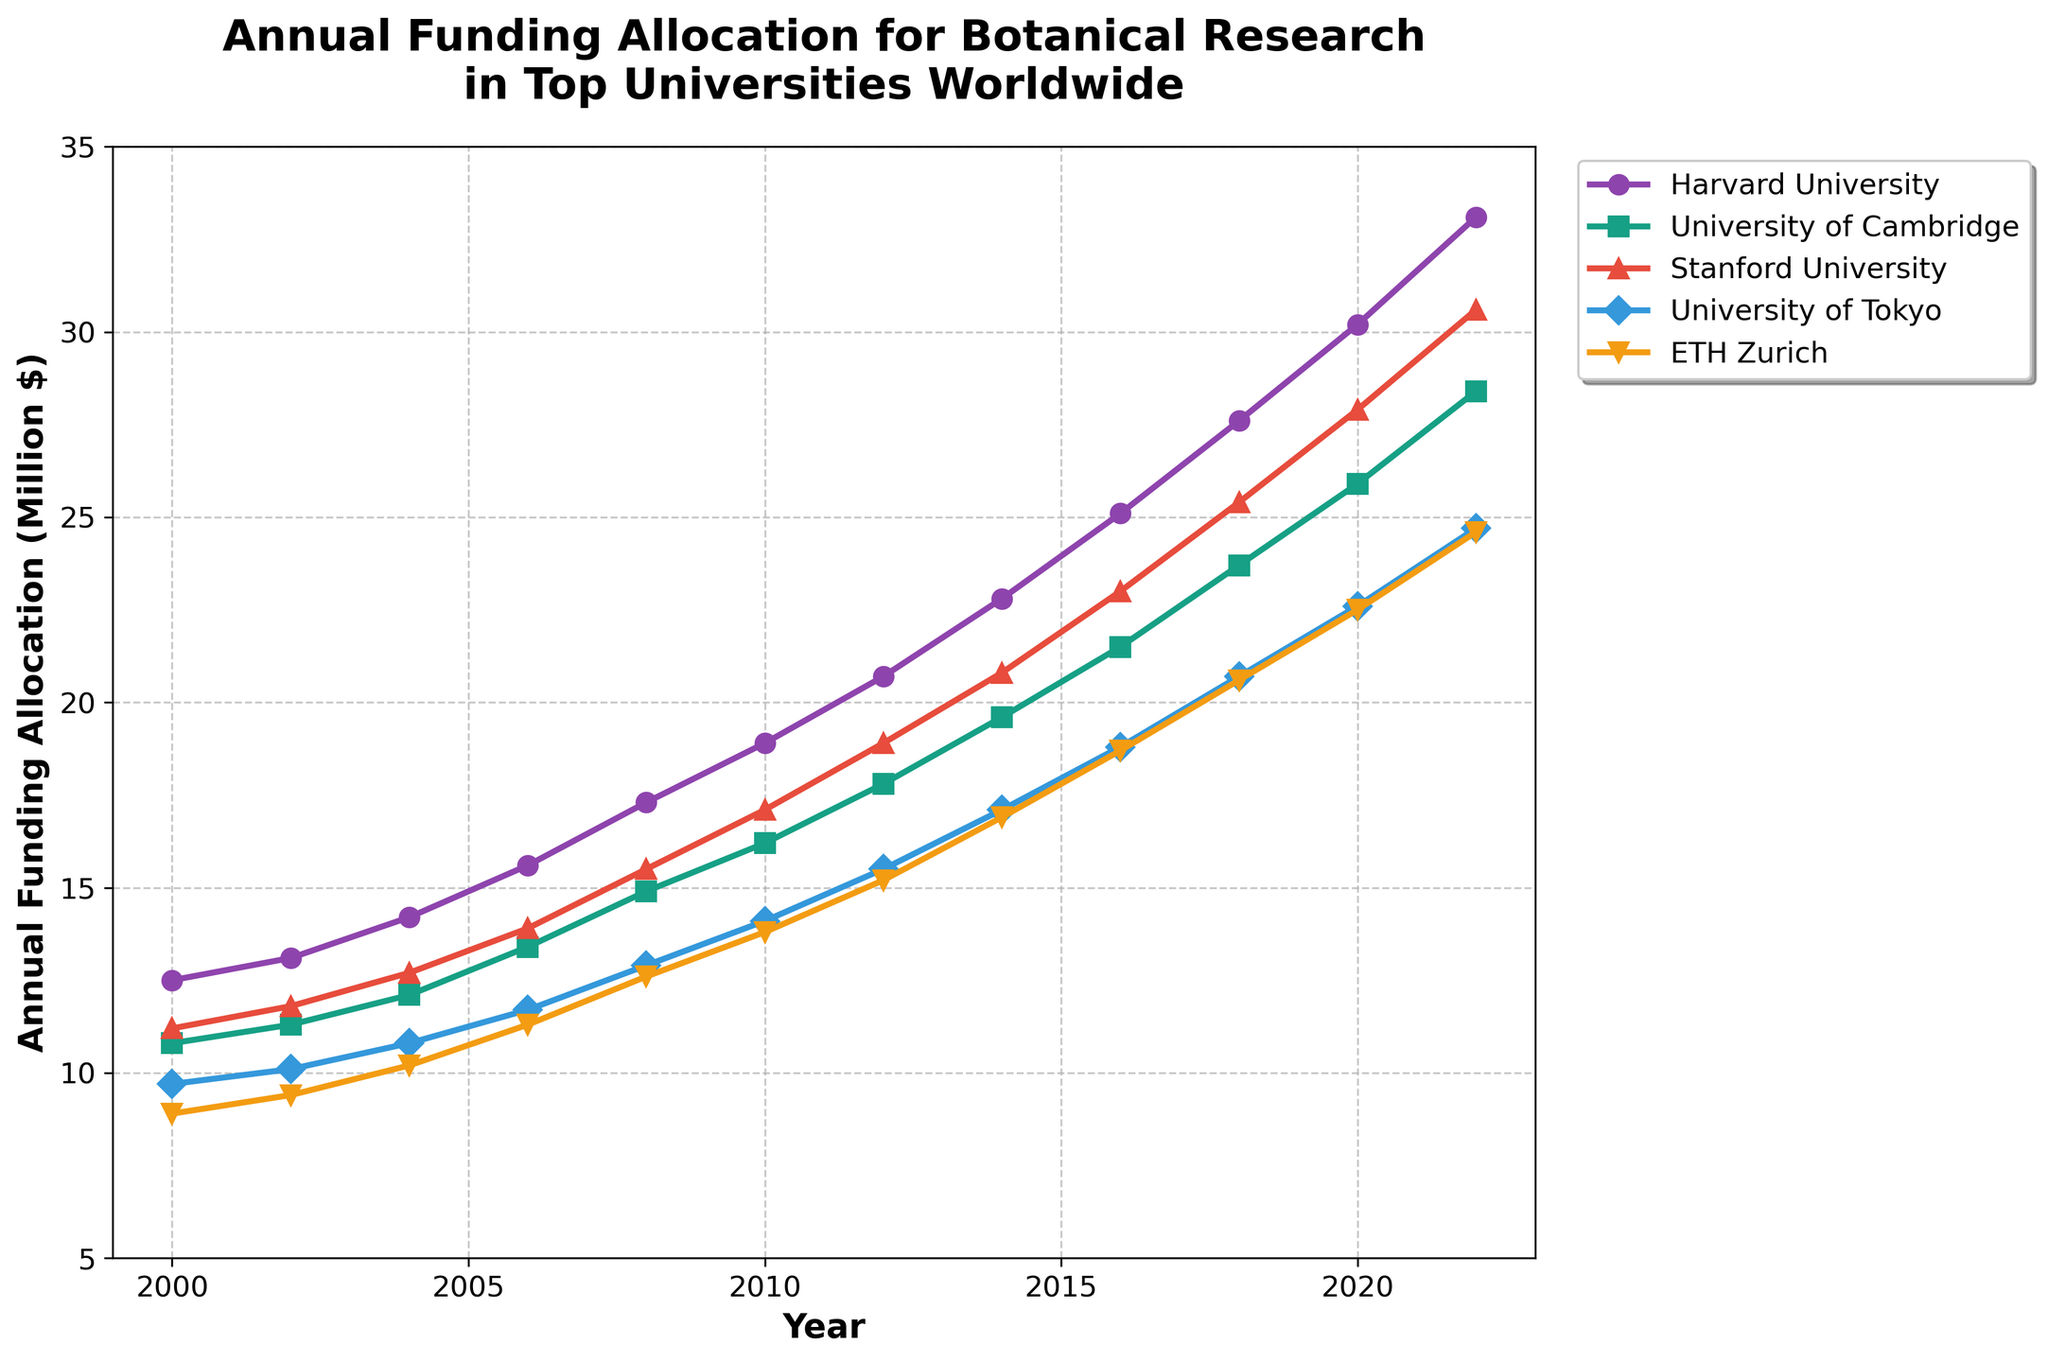Which university had the highest funding allocation in 2022? Look at the values in 2022 on the graph. Identify the university with the highest plot marker.
Answer: Harvard University What was the cumulative funding of all universities in 2010? Sum the 2010 funding allocations for all universities: 18.9 + 16.2 + 17.1 + 14.1 + 13.8
Answer: 80.1 million dollars Which university showed the largest increase in funding from 2000 to 2022? Subtract the 2000 value from the 2022 value for each university: Harvard: 33.1 - 12.5, Cambridge: 28.4 - 10.8, Stanford: 30.6 - 11.2, Tokyo: 24.7 - 9.7, ETH Zurich: 24.6 - 8.9. Compare these results.
Answer: Harvard University Between which two consecutive years did the University of Cambridge experience the highest increase in funding? Calculate the difference for each consecutive dictionary entry and compare: (2002-2000), (2004-2002), and so on through 2022.
Answer: 2020 to 2022 What is the average annual funding allocation for Stanford University from 2000 to 2022? Sum all the values from 2000 to 2022 for Stanford and divide by the number of data points (11 years): (11.2 + 11.8 + 12.7 + 13.9 + 15.5 + 17.1 + 18.9 + 20.8 + 23.0 + 25.4 + 27.9 + 30.6) / 12
Answer: 18.73 million dollars Which university had the least funding allocation in 2006? Identify the lowest plot marker for the year 2006 on the graph.
Answer: ETH Zurich By how much did the annual funding for the University of Tokyo increase from 2016 to 2018? Subtract the 2016 value from the 2018 value for the University of Tokyo: 20.7 - 18.8
Answer: 1.9 million dollars In which year did ETH Zurich have funding closest to 15 million dollars? Identify the year where the funding for ETH Zurich is closest to 15.
Answer: 2012 How much more funding did Harvard University receive compared to ETH Zurich in 2022? Subtract ETH Zurich's 2022 value from Harvard's 2022 value: 33.1 - 24.6
Answer: 8.5 million dollars 